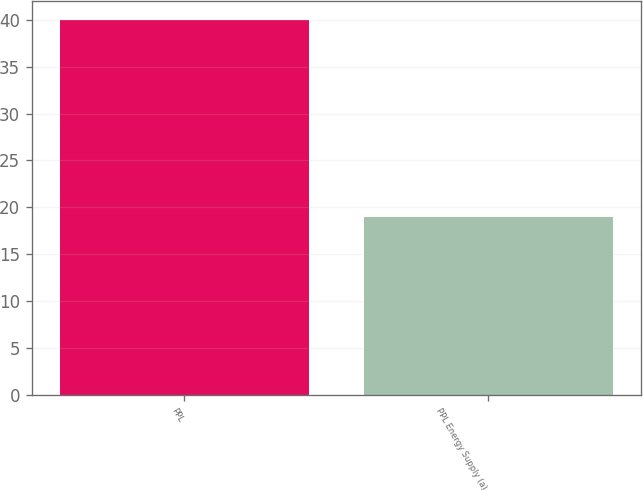Convert chart to OTSL. <chart><loc_0><loc_0><loc_500><loc_500><bar_chart><fcel>PPL<fcel>PPL Energy Supply (a)<nl><fcel>40<fcel>19<nl></chart> 